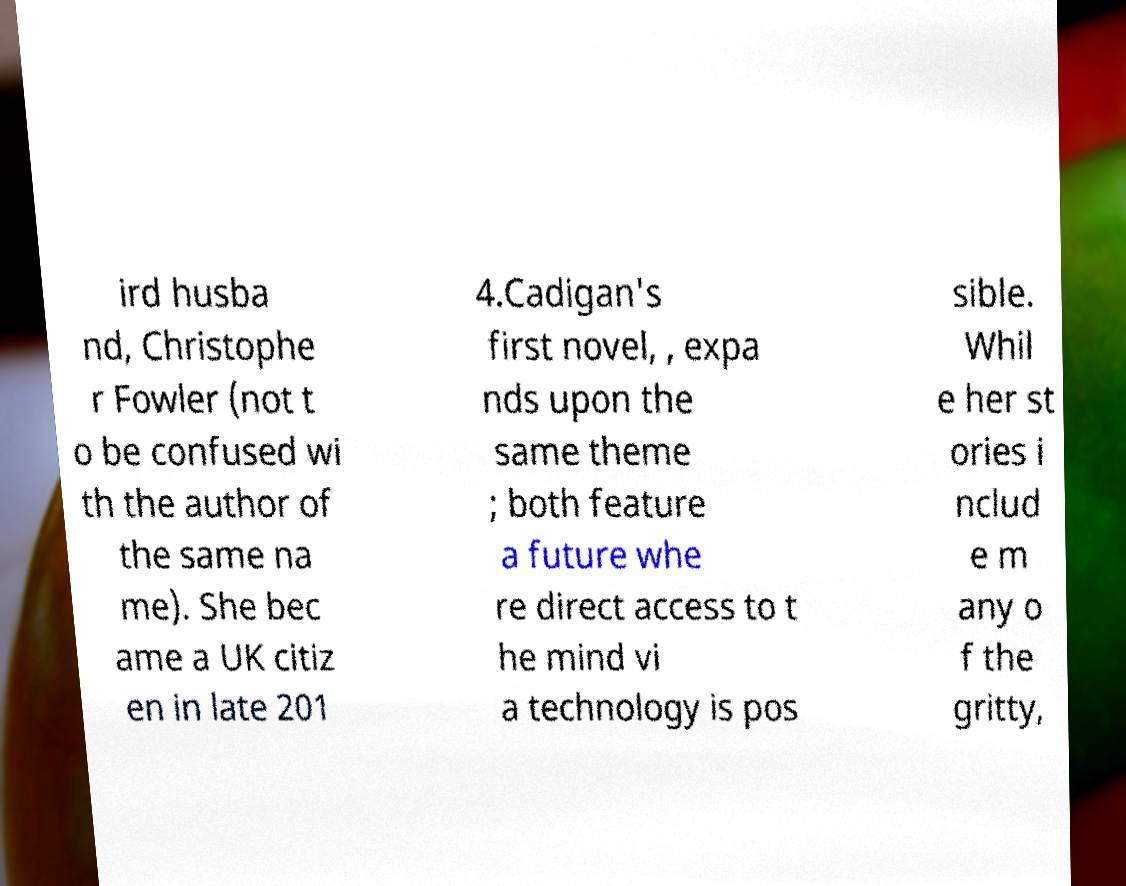What messages or text are displayed in this image? I need them in a readable, typed format. ird husba nd, Christophe r Fowler (not t o be confused wi th the author of the same na me). She bec ame a UK citiz en in late 201 4.Cadigan's first novel, , expa nds upon the same theme ; both feature a future whe re direct access to t he mind vi a technology is pos sible. Whil e her st ories i nclud e m any o f the gritty, 